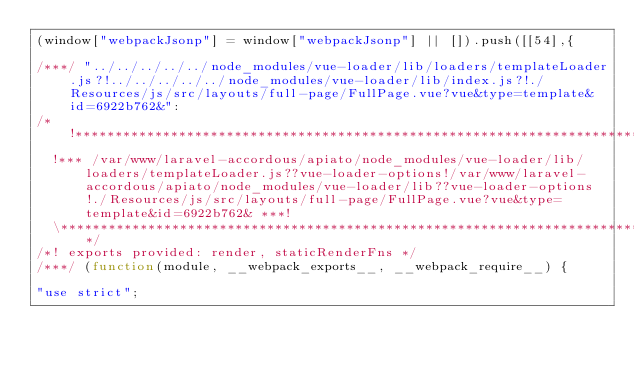Convert code to text. <code><loc_0><loc_0><loc_500><loc_500><_JavaScript_>(window["webpackJsonp"] = window["webpackJsonp"] || []).push([[54],{

/***/ "../../../../../node_modules/vue-loader/lib/loaders/templateLoader.js?!../../../../../node_modules/vue-loader/lib/index.js?!./Resources/js/src/layouts/full-page/FullPage.vue?vue&type=template&id=6922b762&":
/*!**************************************************************************************************************************************************************************************************************************************************************************************!*\
  !*** /var/www/laravel-accordous/apiato/node_modules/vue-loader/lib/loaders/templateLoader.js??vue-loader-options!/var/www/laravel-accordous/apiato/node_modules/vue-loader/lib??vue-loader-options!./Resources/js/src/layouts/full-page/FullPage.vue?vue&type=template&id=6922b762& ***!
  \**************************************************************************************************************************************************************************************************************************************************************************************/
/*! exports provided: render, staticRenderFns */
/***/ (function(module, __webpack_exports__, __webpack_require__) {

"use strict";</code> 